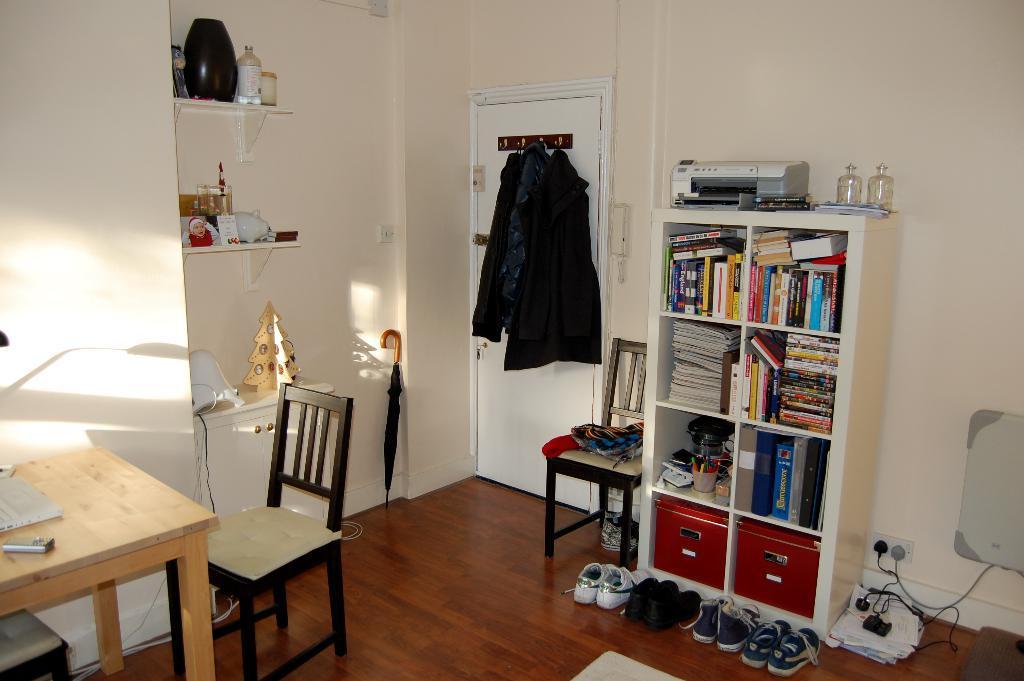In one or two sentences, can you explain what this image depicts? In the center we can see some shirts were hanging on door. Beside door there is a umbrella,and beside umbrella there is a shelf with few objects. In the bottle left corner there is a table along with the chair. And in the right side the bottom they were some shoes, and it contains shelf with full of books. On above the shelf there is a machine. The house is surrounded by many objects. 